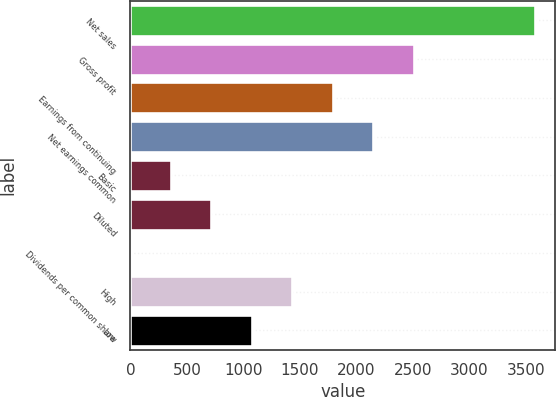Convert chart to OTSL. <chart><loc_0><loc_0><loc_500><loc_500><bar_chart><fcel>Net sales<fcel>Gross profit<fcel>Earnings from continuing<fcel>Net earnings common<fcel>Basic<fcel>Diluted<fcel>Dividends per common share<fcel>High<fcel>Low<nl><fcel>3579<fcel>2505.42<fcel>1789.72<fcel>2147.57<fcel>358.32<fcel>716.17<fcel>0.47<fcel>1431.87<fcel>1074.02<nl></chart> 